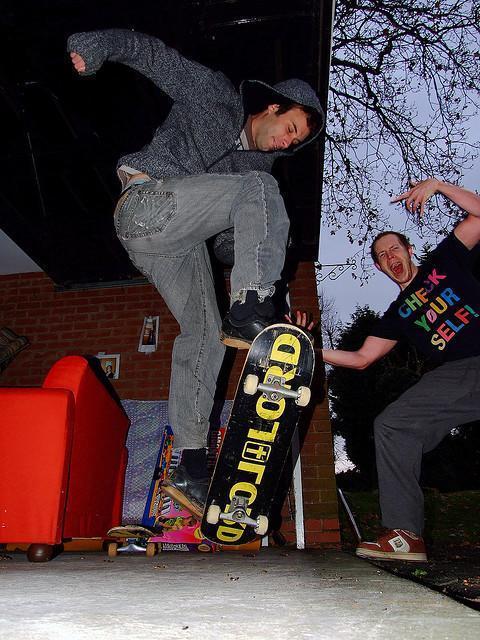How many people are in the photo?
Give a very brief answer. 2. 